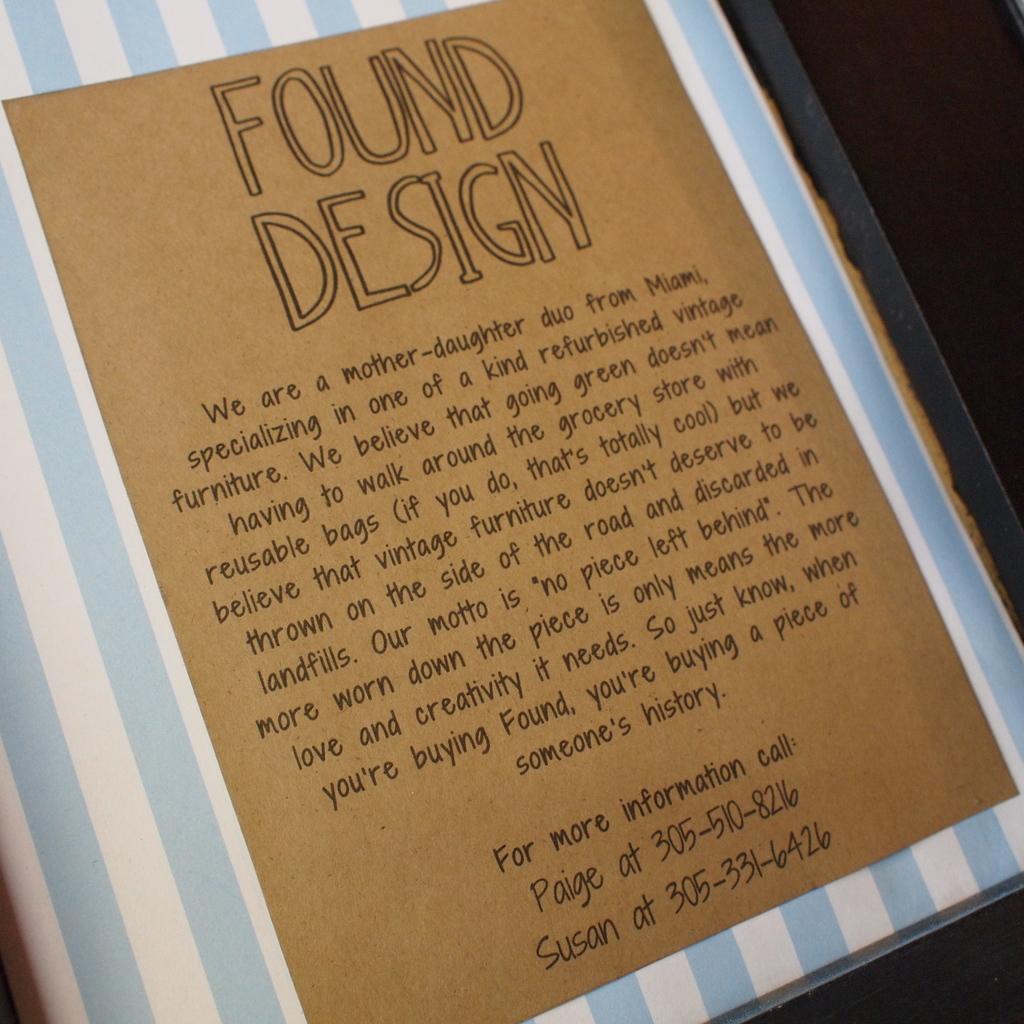What is susan's phone number?
Offer a very short reply. 305-331-6426. 